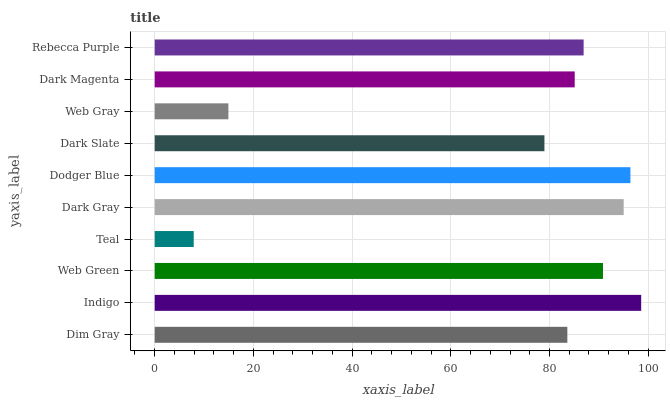Is Teal the minimum?
Answer yes or no. Yes. Is Indigo the maximum?
Answer yes or no. Yes. Is Web Green the minimum?
Answer yes or no. No. Is Web Green the maximum?
Answer yes or no. No. Is Indigo greater than Web Green?
Answer yes or no. Yes. Is Web Green less than Indigo?
Answer yes or no. Yes. Is Web Green greater than Indigo?
Answer yes or no. No. Is Indigo less than Web Green?
Answer yes or no. No. Is Rebecca Purple the high median?
Answer yes or no. Yes. Is Dark Magenta the low median?
Answer yes or no. Yes. Is Web Green the high median?
Answer yes or no. No. Is Web Green the low median?
Answer yes or no. No. 